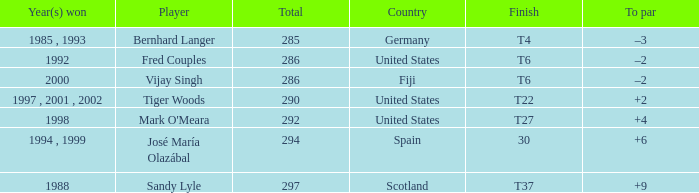Which player has a total of more than 290 and +4 to par. Mark O'Meara. 